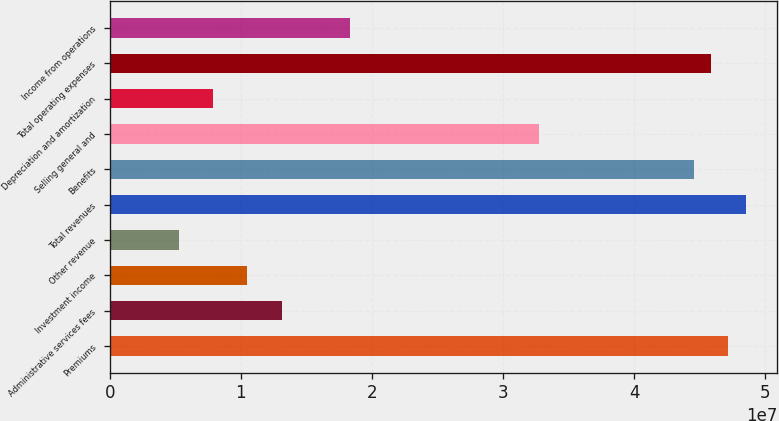Convert chart. <chart><loc_0><loc_0><loc_500><loc_500><bar_chart><fcel>Premiums<fcel>Administrative services fees<fcel>Investment income<fcel>Other revenue<fcel>Total revenues<fcel>Benefits<fcel>Selling general and<fcel>Depreciation and amortization<fcel>Total operating expenses<fcel>Income from operations<nl><fcel>4.71756e+07<fcel>1.31043e+07<fcel>1.04835e+07<fcel>5.24173e+06<fcel>4.8486e+07<fcel>4.45547e+07<fcel>3.27608e+07<fcel>7.8626e+06<fcel>4.58651e+07<fcel>1.83461e+07<nl></chart> 